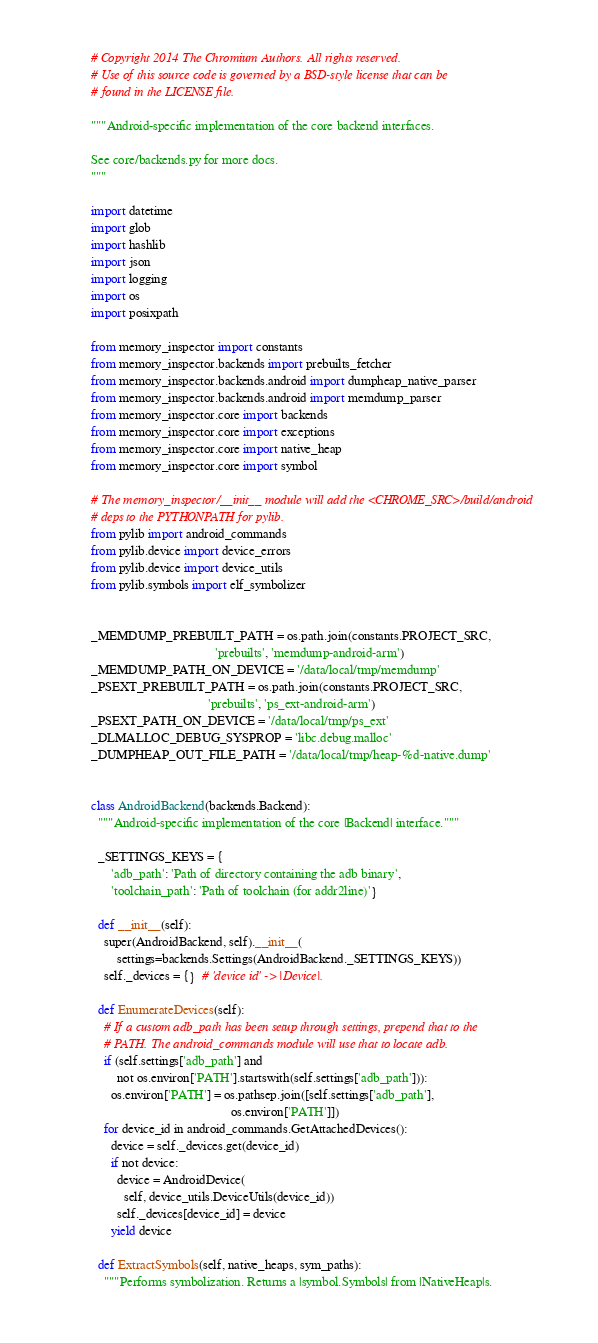Convert code to text. <code><loc_0><loc_0><loc_500><loc_500><_Python_># Copyright 2014 The Chromium Authors. All rights reserved.
# Use of this source code is governed by a BSD-style license that can be
# found in the LICENSE file.

"""Android-specific implementation of the core backend interfaces.

See core/backends.py for more docs.
"""

import datetime
import glob
import hashlib
import json
import logging
import os
import posixpath

from memory_inspector import constants
from memory_inspector.backends import prebuilts_fetcher
from memory_inspector.backends.android import dumpheap_native_parser
from memory_inspector.backends.android import memdump_parser
from memory_inspector.core import backends
from memory_inspector.core import exceptions
from memory_inspector.core import native_heap
from memory_inspector.core import symbol

# The memory_inspector/__init__ module will add the <CHROME_SRC>/build/android
# deps to the PYTHONPATH for pylib.
from pylib import android_commands
from pylib.device import device_errors
from pylib.device import device_utils
from pylib.symbols import elf_symbolizer


_MEMDUMP_PREBUILT_PATH = os.path.join(constants.PROJECT_SRC,
                                      'prebuilts', 'memdump-android-arm')
_MEMDUMP_PATH_ON_DEVICE = '/data/local/tmp/memdump'
_PSEXT_PREBUILT_PATH = os.path.join(constants.PROJECT_SRC,
                                    'prebuilts', 'ps_ext-android-arm')
_PSEXT_PATH_ON_DEVICE = '/data/local/tmp/ps_ext'
_DLMALLOC_DEBUG_SYSPROP = 'libc.debug.malloc'
_DUMPHEAP_OUT_FILE_PATH = '/data/local/tmp/heap-%d-native.dump'


class AndroidBackend(backends.Backend):
  """Android-specific implementation of the core |Backend| interface."""

  _SETTINGS_KEYS = {
      'adb_path': 'Path of directory containing the adb binary',
      'toolchain_path': 'Path of toolchain (for addr2line)'}

  def __init__(self):
    super(AndroidBackend, self).__init__(
        settings=backends.Settings(AndroidBackend._SETTINGS_KEYS))
    self._devices = {}  # 'device id' -> |Device|.

  def EnumerateDevices(self):
    # If a custom adb_path has been setup through settings, prepend that to the
    # PATH. The android_commands module will use that to locate adb.
    if (self.settings['adb_path'] and
        not os.environ['PATH'].startswith(self.settings['adb_path'])):
      os.environ['PATH'] = os.pathsep.join([self.settings['adb_path'],
                                           os.environ['PATH']])
    for device_id in android_commands.GetAttachedDevices():
      device = self._devices.get(device_id)
      if not device:
        device = AndroidDevice(
          self, device_utils.DeviceUtils(device_id))
        self._devices[device_id] = device
      yield device

  def ExtractSymbols(self, native_heaps, sym_paths):
    """Performs symbolization. Returns a |symbol.Symbols| from |NativeHeap|s.
</code> 